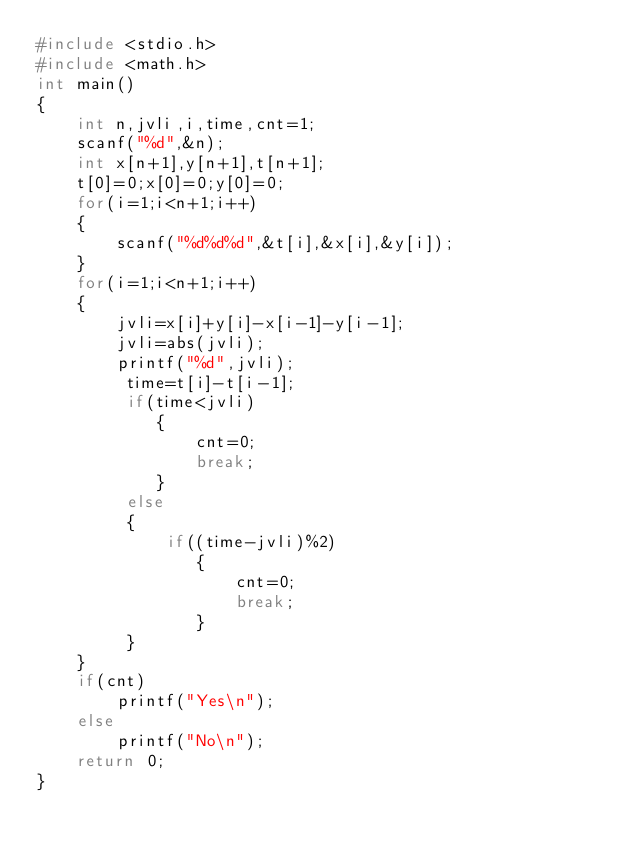<code> <loc_0><loc_0><loc_500><loc_500><_C_>#include <stdio.h>
#include <math.h>
int main()
{
    int n,jvli,i,time,cnt=1;
    scanf("%d",&n);
    int x[n+1],y[n+1],t[n+1];
    t[0]=0;x[0]=0;y[0]=0;
    for(i=1;i<n+1;i++)
    {
        scanf("%d%d%d",&t[i],&x[i],&y[i]);
    }
    for(i=1;i<n+1;i++)
    {
        jvli=x[i]+y[i]-x[i-1]-y[i-1];
        jvli=abs(jvli);
        printf("%d",jvli);
         time=t[i]-t[i-1];
         if(time<jvli)
            {
                cnt=0;
                break;
            }
         else
         {
             if((time-jvli)%2)
                {
                    cnt=0;
                    break;
                }
         }
    }
    if(cnt)
        printf("Yes\n");
    else
        printf("No\n");
    return 0;
}</code> 